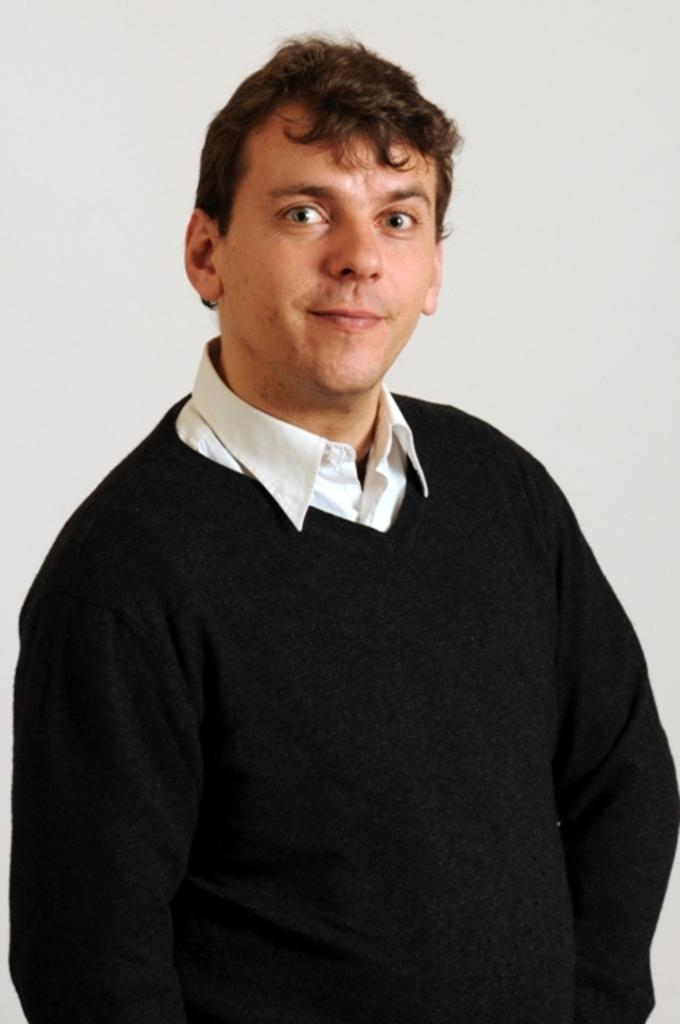What is present in the image? There is a person in the image. What is the person doing in the image? The person is standing in the image. How is the person's facial expression in the image? The person is smiling in the image. What type of shoes is the person wearing in the image? The provided facts do not mention shoes, so we cannot determine the type of shoes the person is wearing in the image. 